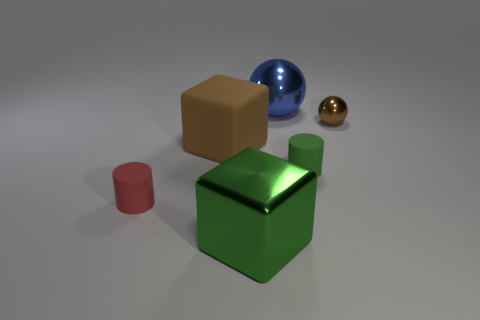What is the material of the block that is in front of the green cylinder?
Offer a very short reply. Metal. Is the material of the cylinder that is behind the tiny red cylinder the same as the cube in front of the red rubber cylinder?
Your response must be concise. No. Are there an equal number of large green blocks that are to the left of the small shiny ball and big brown cubes to the right of the brown block?
Give a very brief answer. No. What number of large blue cubes have the same material as the large blue thing?
Provide a succinct answer. 0. There is a tiny metallic thing that is the same color as the matte cube; what is its shape?
Make the answer very short. Sphere. There is a object that is behind the ball that is in front of the large blue metal ball; what size is it?
Your answer should be compact. Large. Does the brown thing on the left side of the brown sphere have the same shape as the object in front of the red rubber cylinder?
Your answer should be very brief. Yes. Is the number of balls that are to the left of the red cylinder the same as the number of large purple objects?
Make the answer very short. Yes. What is the color of the other thing that is the same shape as the tiny red rubber thing?
Keep it short and to the point. Green. Is the green object that is to the right of the blue sphere made of the same material as the brown sphere?
Keep it short and to the point. No. 